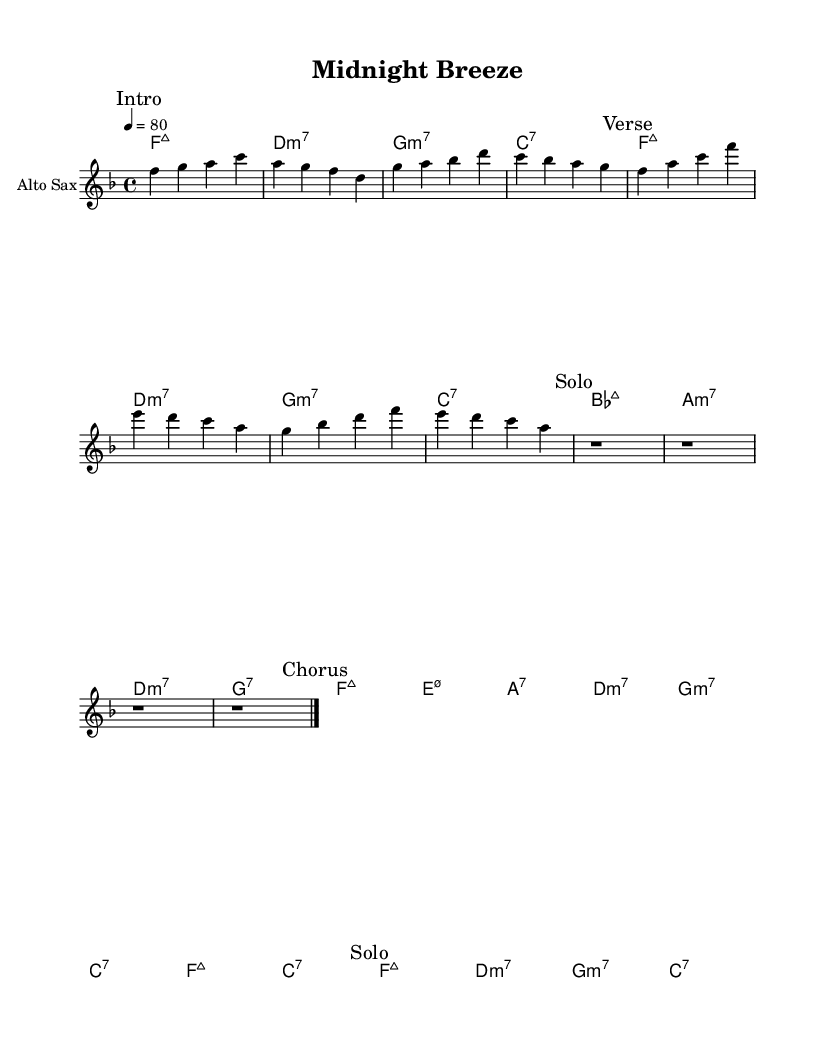What is the key signature of this music? The key signature is F major, which has one flat (B flat).
Answer: F major What is the time signature of this music? The time signature indicated is 4/4, meaning there are four beats in each measure.
Answer: 4/4 What is the tempo marking for this piece? The tempo marking is "4 = 80," which indicates a moderate pace.
Answer: 80 How many measures are in the chorus section? The chorus section is outlined and consists of 8 measures in total.
Answer: 8 What is the instrument specified for the melodic part? The specified instrument for the melodic part is "Alto Sax," indicating it's written for the alto saxophone.
Answer: Alto Sax What type of chords are used in the intro? The chords in the intro are "F major seventh," "D minor seventh," "G minor seventh," and "C seventh."
Answer: Major seventh and minor seventh What is the function of the 'Solo' section in the piece? The 'Solo' section is designed for improvisation or a more expressive musical line featuring the saxophone, allowing for individual expression and creativity.
Answer: Improvisation 